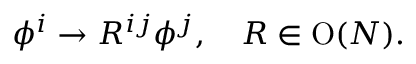<formula> <loc_0><loc_0><loc_500><loc_500>\phi ^ { i } \to R ^ { i j } \phi ^ { j } , \quad R \in O ( N ) .</formula> 